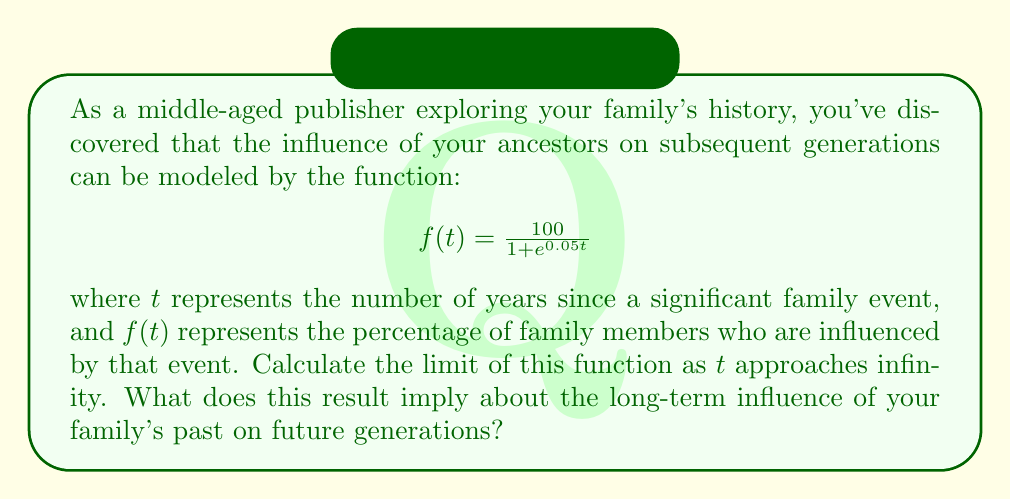Show me your answer to this math problem. To solve this problem, we need to evaluate the limit of the given function as $t$ approaches infinity:

$$\lim_{t \to \infty} f(t) = \lim_{t \to \infty} \frac{100}{1 + e^{0.05t}}$$

Let's approach this step-by-step:

1) As $t$ approaches infinity, $e^{0.05t}$ will also approach infinity because the exponential function grows faster than any polynomial function.

2) When the denominator grows infinitely large, the fraction will approach zero:

   $$\lim_{t \to \infty} \frac{100}{1 + e^{0.05t}} = \frac{100}{\infty} = 0$$

3) We can verify this result using the Squeeze Theorem:

   $$0 \leq \frac{100}{1 + e^{0.05t}} \leq \frac{100}{e^{0.05t}}$$

   As $t \to \infty$, both $\frac{100}{e^{0.05t}}$ and $0$ approach 0, so the function $f(t)$ must also approach 0.

This result implies that as time approaches infinity, the influence of the family's past event on future generations approaches 0%. In other words, the direct influence of a single historical event diminishes over time, approaching insignificance in the very long term.

However, it's important to note that while the mathematical limit approaches zero, the cumulative effect of multiple historical events and the ongoing creation of family history may maintain a significant influence on future generations, even if individual past events become less directly impactful.
Answer: The limit of the function as $t$ approaches infinity is 0:

$$\lim_{t \to \infty} f(t) = \lim_{t \to \infty} \frac{100}{1 + e^{0.05t}} = 0$$

This implies that the direct influence of a single historical family event approaches 0% as time goes to infinity. 